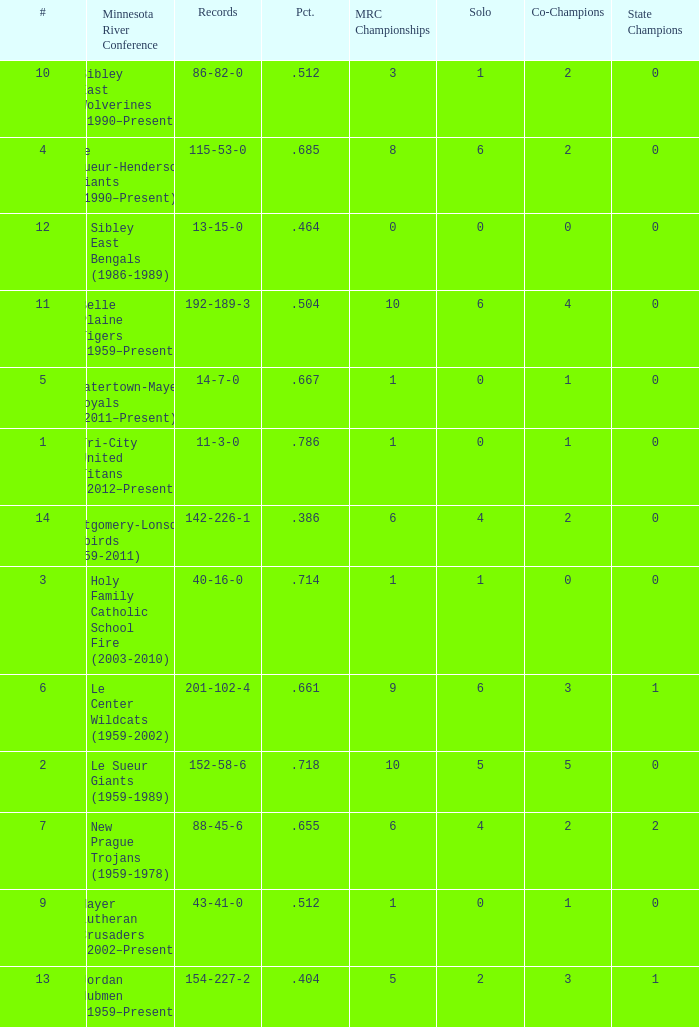How many teams are #2 on the list? 1.0. 